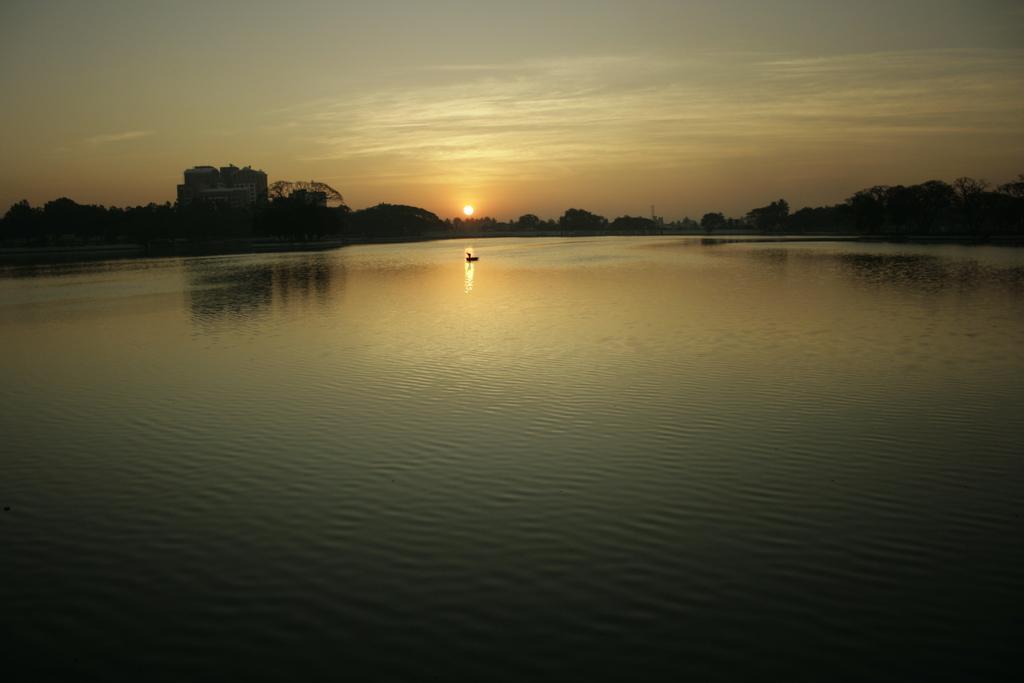In one or two sentences, can you explain what this image depicts? In this image there is the sky towards the top of the image, there is the sun in the sky, there is a building, there are trees, there is water towards the bottom of the image, there is an object in the water. 